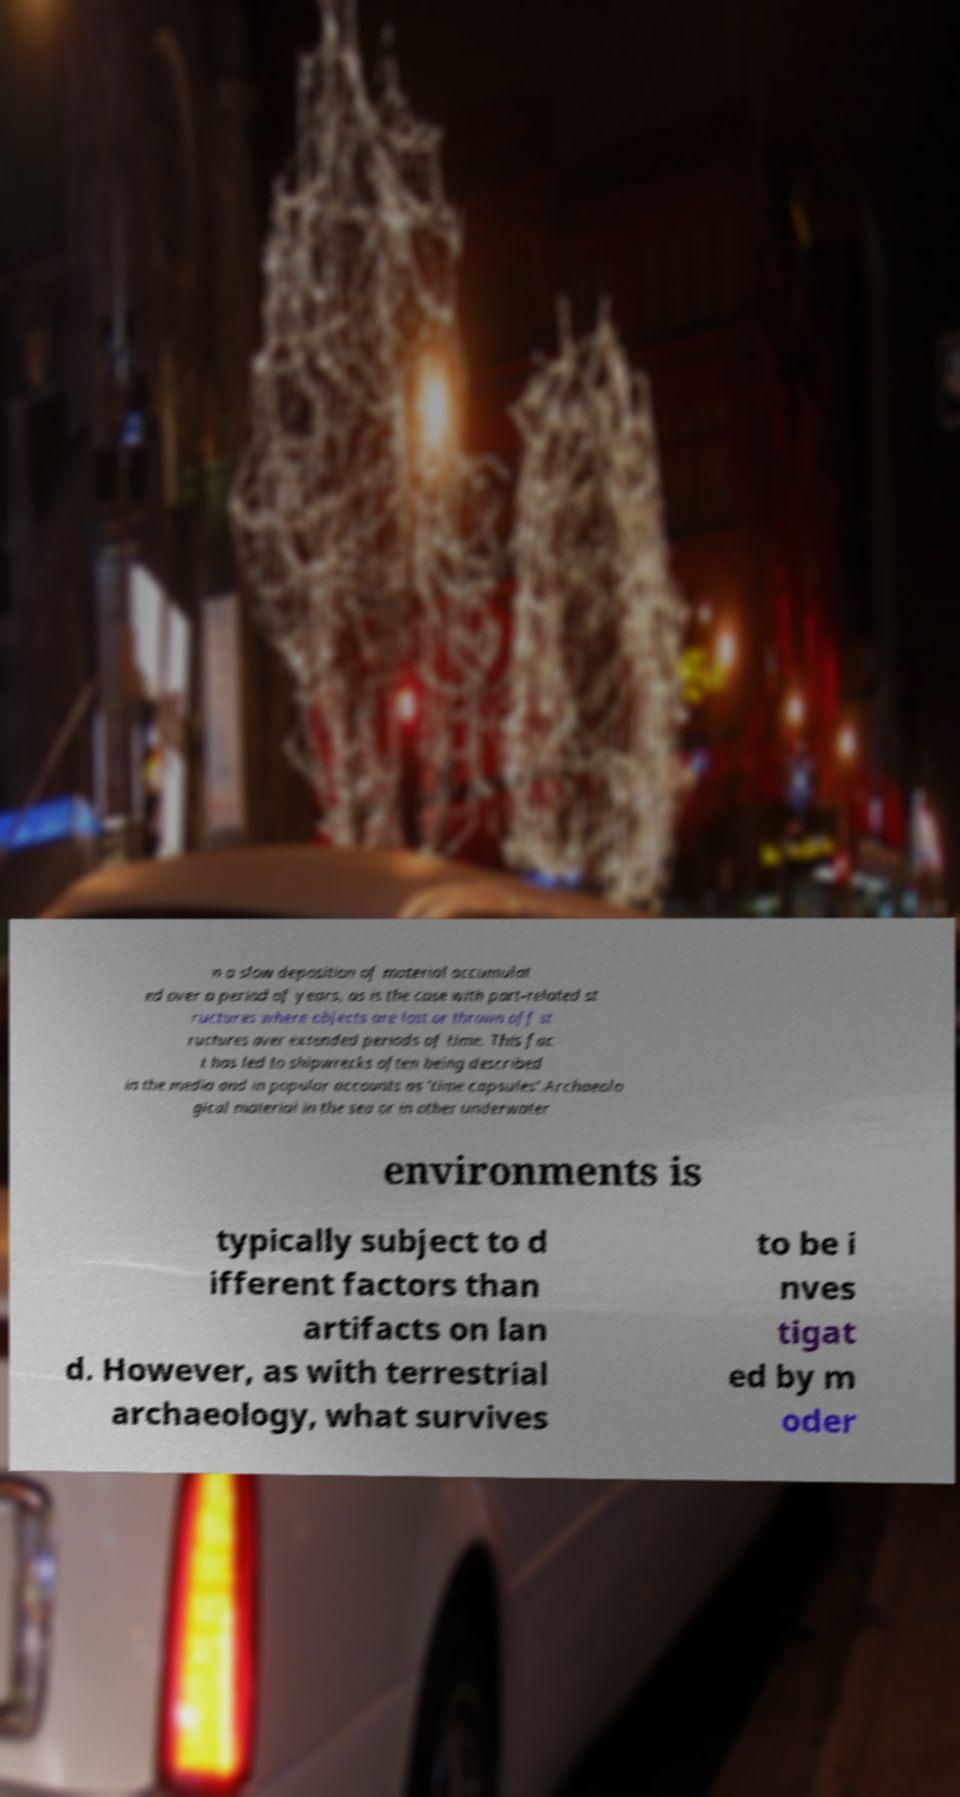There's text embedded in this image that I need extracted. Can you transcribe it verbatim? n a slow deposition of material accumulat ed over a period of years, as is the case with port-related st ructures where objects are lost or thrown off st ructures over extended periods of time. This fac t has led to shipwrecks often being described in the media and in popular accounts as 'time capsules'.Archaeolo gical material in the sea or in other underwater environments is typically subject to d ifferent factors than artifacts on lan d. However, as with terrestrial archaeology, what survives to be i nves tigat ed by m oder 